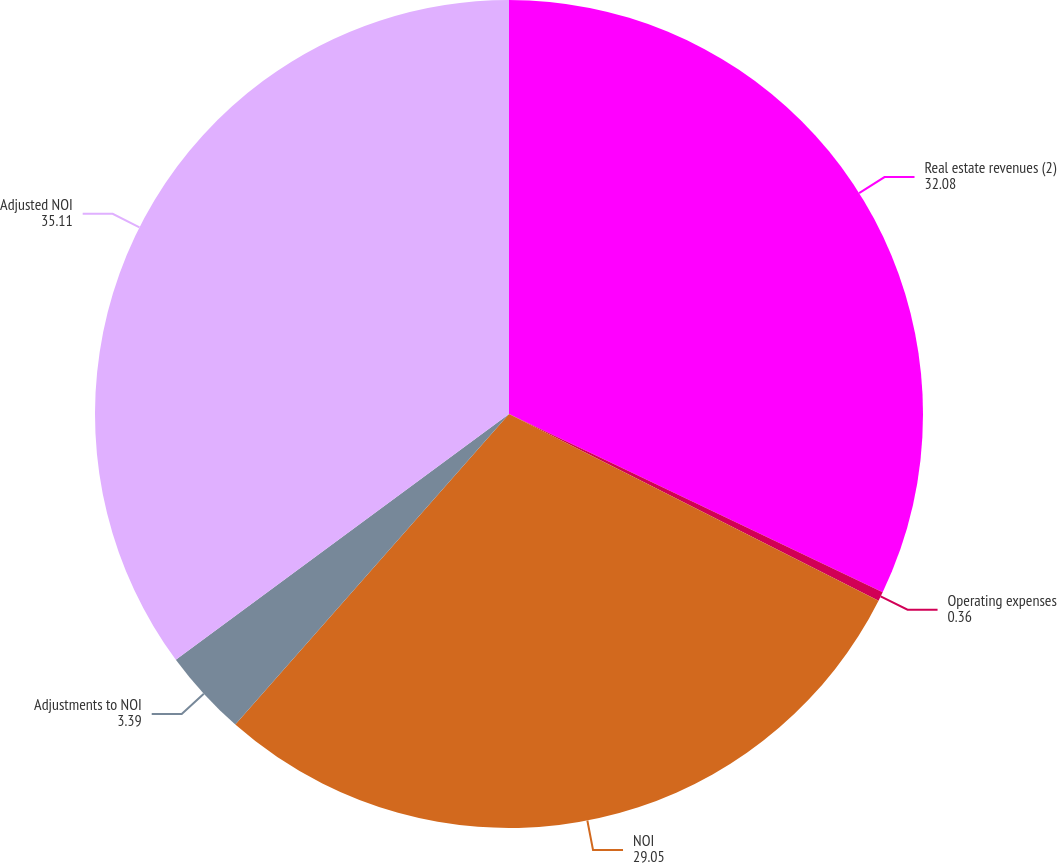<chart> <loc_0><loc_0><loc_500><loc_500><pie_chart><fcel>Real estate revenues (2)<fcel>Operating expenses<fcel>NOI<fcel>Adjustments to NOI<fcel>Adjusted NOI<nl><fcel>32.08%<fcel>0.36%<fcel>29.05%<fcel>3.39%<fcel>35.11%<nl></chart> 